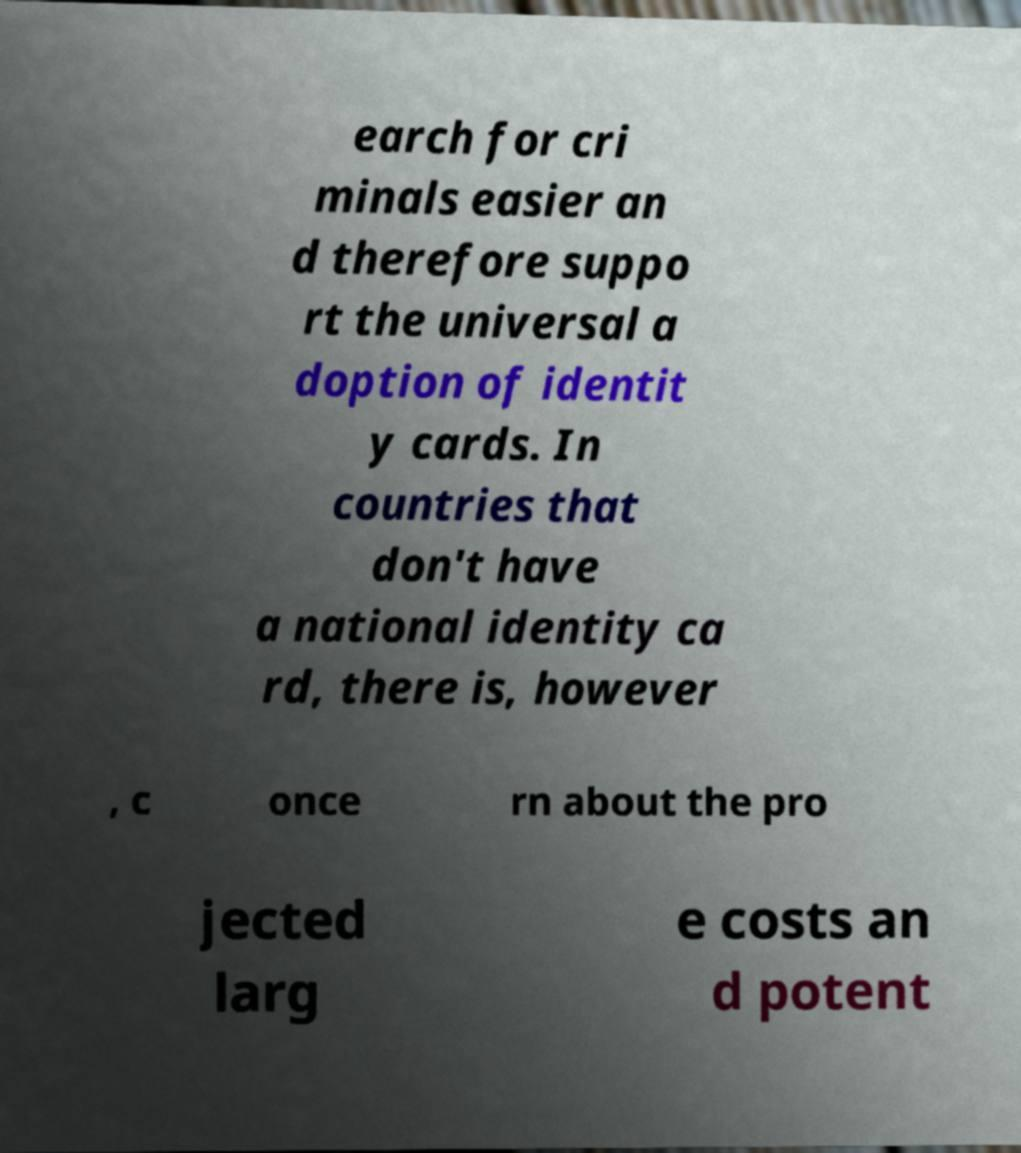Please identify and transcribe the text found in this image. earch for cri minals easier an d therefore suppo rt the universal a doption of identit y cards. In countries that don't have a national identity ca rd, there is, however , c once rn about the pro jected larg e costs an d potent 